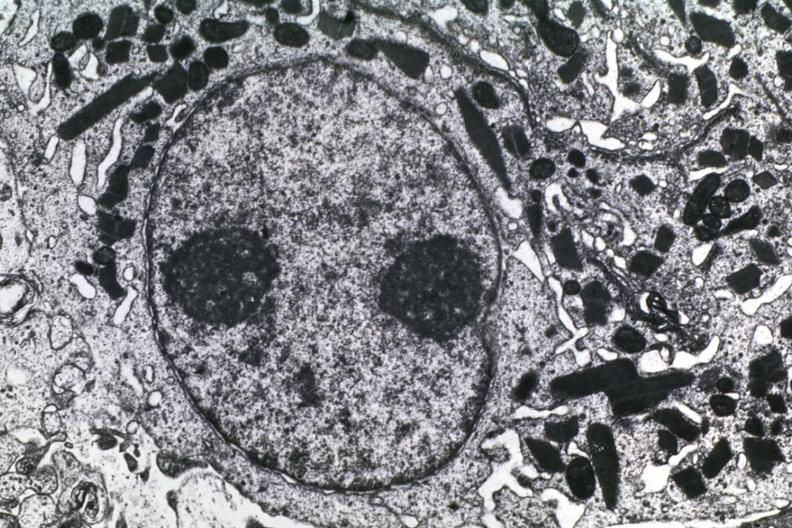what does this image show?
Answer the question using a single word or phrase. Dr garcia tumors 57 